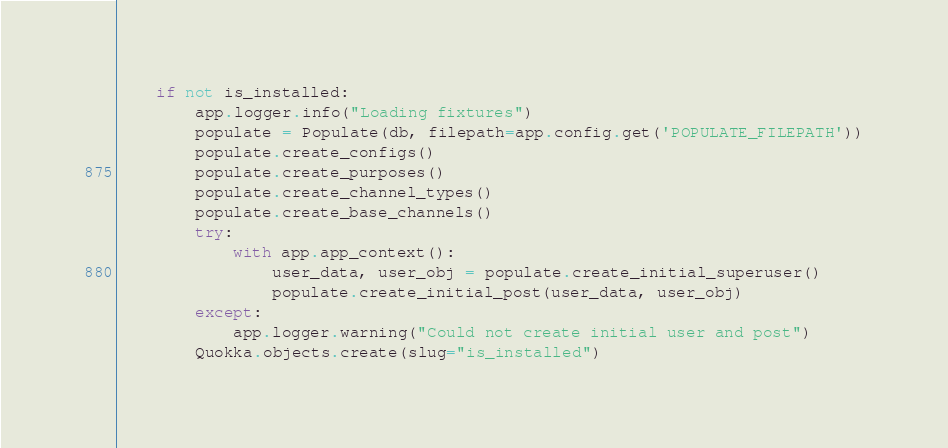<code> <loc_0><loc_0><loc_500><loc_500><_Python_>    if not is_installed:
        app.logger.info("Loading fixtures")
        populate = Populate(db, filepath=app.config.get('POPULATE_FILEPATH'))
        populate.create_configs()
        populate.create_purposes()
        populate.create_channel_types()
        populate.create_base_channels()
        try:
            with app.app_context():
                user_data, user_obj = populate.create_initial_superuser()
                populate.create_initial_post(user_data, user_obj)
        except:
            app.logger.warning("Could not create initial user and post")
        Quokka.objects.create(slug="is_installed")
</code> 